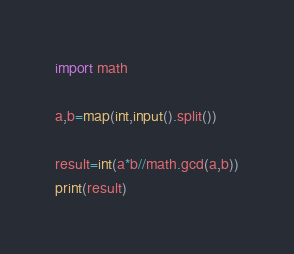<code> <loc_0><loc_0><loc_500><loc_500><_Python_>import math

a,b=map(int,input().split())

result=int(a*b//math.gcd(a,b))
print(result)</code> 